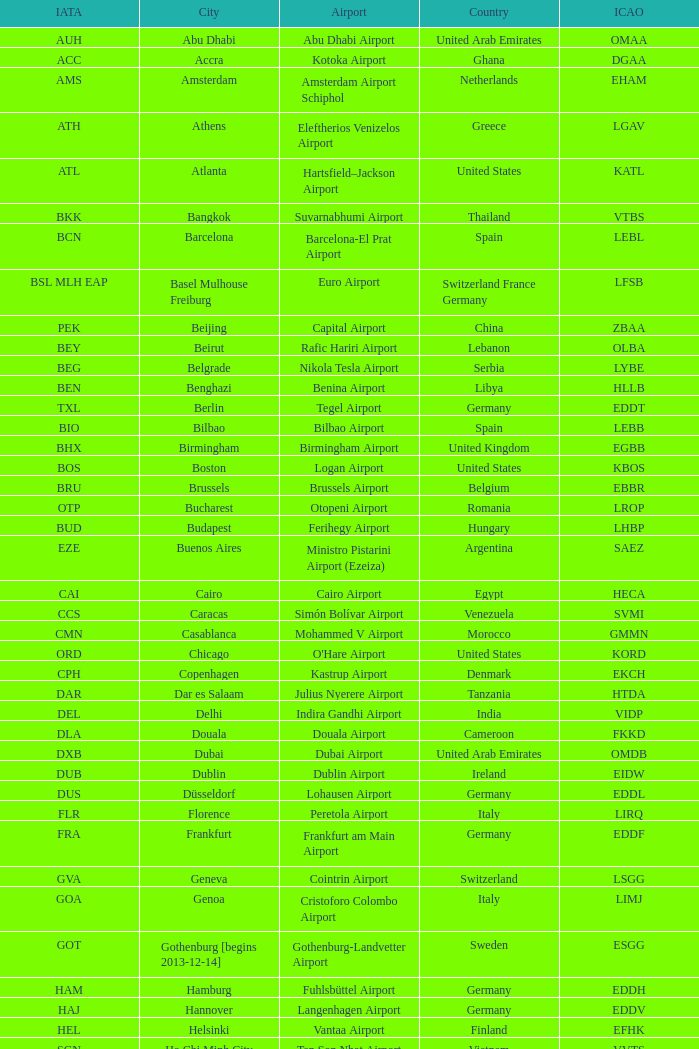Could you parse the entire table? {'header': ['IATA', 'City', 'Airport', 'Country', 'ICAO'], 'rows': [['AUH', 'Abu Dhabi', 'Abu Dhabi Airport', 'United Arab Emirates', 'OMAA'], ['ACC', 'Accra', 'Kotoka Airport', 'Ghana', 'DGAA'], ['AMS', 'Amsterdam', 'Amsterdam Airport Schiphol', 'Netherlands', 'EHAM'], ['ATH', 'Athens', 'Eleftherios Venizelos Airport', 'Greece', 'LGAV'], ['ATL', 'Atlanta', 'Hartsfield–Jackson Airport', 'United States', 'KATL'], ['BKK', 'Bangkok', 'Suvarnabhumi Airport', 'Thailand', 'VTBS'], ['BCN', 'Barcelona', 'Barcelona-El Prat Airport', 'Spain', 'LEBL'], ['BSL MLH EAP', 'Basel Mulhouse Freiburg', 'Euro Airport', 'Switzerland France Germany', 'LFSB'], ['PEK', 'Beijing', 'Capital Airport', 'China', 'ZBAA'], ['BEY', 'Beirut', 'Rafic Hariri Airport', 'Lebanon', 'OLBA'], ['BEG', 'Belgrade', 'Nikola Tesla Airport', 'Serbia', 'LYBE'], ['BEN', 'Benghazi', 'Benina Airport', 'Libya', 'HLLB'], ['TXL', 'Berlin', 'Tegel Airport', 'Germany', 'EDDT'], ['BIO', 'Bilbao', 'Bilbao Airport', 'Spain', 'LEBB'], ['BHX', 'Birmingham', 'Birmingham Airport', 'United Kingdom', 'EGBB'], ['BOS', 'Boston', 'Logan Airport', 'United States', 'KBOS'], ['BRU', 'Brussels', 'Brussels Airport', 'Belgium', 'EBBR'], ['OTP', 'Bucharest', 'Otopeni Airport', 'Romania', 'LROP'], ['BUD', 'Budapest', 'Ferihegy Airport', 'Hungary', 'LHBP'], ['EZE', 'Buenos Aires', 'Ministro Pistarini Airport (Ezeiza)', 'Argentina', 'SAEZ'], ['CAI', 'Cairo', 'Cairo Airport', 'Egypt', 'HECA'], ['CCS', 'Caracas', 'Simón Bolívar Airport', 'Venezuela', 'SVMI'], ['CMN', 'Casablanca', 'Mohammed V Airport', 'Morocco', 'GMMN'], ['ORD', 'Chicago', "O'Hare Airport", 'United States', 'KORD'], ['CPH', 'Copenhagen', 'Kastrup Airport', 'Denmark', 'EKCH'], ['DAR', 'Dar es Salaam', 'Julius Nyerere Airport', 'Tanzania', 'HTDA'], ['DEL', 'Delhi', 'Indira Gandhi Airport', 'India', 'VIDP'], ['DLA', 'Douala', 'Douala Airport', 'Cameroon', 'FKKD'], ['DXB', 'Dubai', 'Dubai Airport', 'United Arab Emirates', 'OMDB'], ['DUB', 'Dublin', 'Dublin Airport', 'Ireland', 'EIDW'], ['DUS', 'Düsseldorf', 'Lohausen Airport', 'Germany', 'EDDL'], ['FLR', 'Florence', 'Peretola Airport', 'Italy', 'LIRQ'], ['FRA', 'Frankfurt', 'Frankfurt am Main Airport', 'Germany', 'EDDF'], ['GVA', 'Geneva', 'Cointrin Airport', 'Switzerland', 'LSGG'], ['GOA', 'Genoa', 'Cristoforo Colombo Airport', 'Italy', 'LIMJ'], ['GOT', 'Gothenburg [begins 2013-12-14]', 'Gothenburg-Landvetter Airport', 'Sweden', 'ESGG'], ['HAM', 'Hamburg', 'Fuhlsbüttel Airport', 'Germany', 'EDDH'], ['HAJ', 'Hannover', 'Langenhagen Airport', 'Germany', 'EDDV'], ['HEL', 'Helsinki', 'Vantaa Airport', 'Finland', 'EFHK'], ['SGN', 'Ho Chi Minh City', 'Tan Son Nhat Airport', 'Vietnam', 'VVTS'], ['HKG', 'Hong Kong', 'Chek Lap Kok Airport', 'Hong Kong', 'VHHH'], ['IST', 'Istanbul', 'Atatürk Airport', 'Turkey', 'LTBA'], ['CGK', 'Jakarta', 'Soekarno–Hatta Airport', 'Indonesia', 'WIII'], ['JED', 'Jeddah', 'King Abdulaziz Airport', 'Saudi Arabia', 'OEJN'], ['JNB', 'Johannesburg', 'OR Tambo Airport', 'South Africa', 'FAJS'], ['KHI', 'Karachi', 'Jinnah Airport', 'Pakistan', 'OPKC'], ['KBP', 'Kiev', 'Boryspil International Airport', 'Ukraine', 'UKBB'], ['LOS', 'Lagos', 'Murtala Muhammed Airport', 'Nigeria', 'DNMM'], ['LBV', 'Libreville', "Leon M'ba Airport", 'Gabon', 'FOOL'], ['LIS', 'Lisbon', 'Portela Airport', 'Portugal', 'LPPT'], ['LCY', 'London', 'City Airport', 'United Kingdom', 'EGLC'], ['LGW', 'London [begins 2013-12-14]', 'Gatwick Airport', 'United Kingdom', 'EGKK'], ['LHR', 'London', 'Heathrow Airport', 'United Kingdom', 'EGLL'], ['LAX', 'Los Angeles', 'Los Angeles International Airport', 'United States', 'KLAX'], ['LUG', 'Lugano', 'Agno Airport', 'Switzerland', 'LSZA'], ['LUX', 'Luxembourg City', 'Findel Airport', 'Luxembourg', 'ELLX'], ['LYS', 'Lyon', 'Saint-Exupéry Airport', 'France', 'LFLL'], ['MAD', 'Madrid', 'Madrid-Barajas Airport', 'Spain', 'LEMD'], ['SSG', 'Malabo', 'Saint Isabel Airport', 'Equatorial Guinea', 'FGSL'], ['AGP', 'Malaga', 'Málaga-Costa del Sol Airport', 'Spain', 'LEMG'], ['MAN', 'Manchester', 'Ringway Airport', 'United Kingdom', 'EGCC'], ['MNL', 'Manila', 'Ninoy Aquino Airport', 'Philippines', 'RPLL'], ['RAK', 'Marrakech [begins 2013-11-01]', 'Menara Airport', 'Morocco', 'GMMX'], ['MIA', 'Miami', 'Miami Airport', 'United States', 'KMIA'], ['MXP', 'Milan', 'Malpensa Airport', 'Italy', 'LIMC'], ['MSP', 'Minneapolis', 'Minneapolis Airport', 'United States', 'KMSP'], ['YUL', 'Montreal', 'Pierre Elliott Trudeau Airport', 'Canada', 'CYUL'], ['DME', 'Moscow', 'Domodedovo Airport', 'Russia', 'UUDD'], ['BOM', 'Mumbai', 'Chhatrapati Shivaji Airport', 'India', 'VABB'], ['MUC', 'Munich', 'Franz Josef Strauss Airport', 'Germany', 'EDDM'], ['MCT', 'Muscat', 'Seeb Airport', 'Oman', 'OOMS'], ['NBO', 'Nairobi', 'Jomo Kenyatta Airport', 'Kenya', 'HKJK'], ['EWR', 'Newark', 'Liberty Airport', 'United States', 'KEWR'], ['JFK', 'New York City', 'John F Kennedy Airport', 'United States', 'KJFK'], ['NCE', 'Nice', "Côte d'Azur Airport", 'France', 'LFMN'], ['NUE', 'Nuremberg', 'Nuremberg Airport', 'Germany', 'EDDN'], ['OSL', 'Oslo', 'Gardermoen Airport', 'Norway', 'ENGM'], ['PMI', 'Palma de Mallorca', 'Palma de Mallorca Airport', 'Spain', 'LFPA'], ['CDG', 'Paris', 'Charles de Gaulle Airport', 'France', 'LFPG'], ['OPO', 'Porto', 'Francisco de Sa Carneiro Airport', 'Portugal', 'LPPR'], ['PRG', 'Prague', 'Ruzyně Airport', 'Czech Republic', 'LKPR'], ['RIX', 'Riga', 'Riga Airport', 'Latvia', 'EVRA'], ['GIG', 'Rio de Janeiro [resumes 2014-7-14]', 'Galeão Airport', 'Brazil', 'SBGL'], ['RUH', 'Riyadh', 'King Khalid Airport', 'Saudi Arabia', 'OERK'], ['FCO', 'Rome', 'Leonardo da Vinci Airport', 'Italy', 'LIRF'], ['LED', 'Saint Petersburg', 'Pulkovo Airport', 'Russia', 'ULLI'], ['SFO', 'San Francisco', 'San Francisco Airport', 'United States', 'KSFO'], ['SCL', 'Santiago', 'Comodoro Arturo Benitez Airport', 'Chile', 'SCEL'], ['GRU', 'São Paulo', 'Guarulhos Airport', 'Brazil', 'SBGR'], ['SJJ', 'Sarajevo', 'Butmir Airport', 'Bosnia and Herzegovina', 'LQSA'], ['SEA', 'Seattle', 'Sea-Tac Airport', 'United States', 'KSEA'], ['PVG', 'Shanghai', 'Pudong Airport', 'China', 'ZSPD'], ['SIN', 'Singapore', 'Changi Airport', 'Singapore', 'WSSS'], ['SKP', 'Skopje', 'Alexander the Great Airport', 'Republic of Macedonia', 'LWSK'], ['SOF', 'Sofia', 'Vrazhdebna Airport', 'Bulgaria', 'LBSF'], ['ARN', 'Stockholm', 'Arlanda Airport', 'Sweden', 'ESSA'], ['STR', 'Stuttgart', 'Echterdingen Airport', 'Germany', 'EDDS'], ['TPE', 'Taipei', 'Taoyuan Airport', 'Taiwan', 'RCTP'], ['IKA', 'Tehran', 'Imam Khomeini Airport', 'Iran', 'OIIE'], ['TLV', 'Tel Aviv', 'Ben Gurion Airport', 'Israel', 'LLBG'], ['SKG', 'Thessaloniki', 'Macedonia Airport', 'Greece', 'LGTS'], ['TIA', 'Tirana', 'Nënë Tereza Airport', 'Albania', 'LATI'], ['NRT', 'Tokyo', 'Narita Airport', 'Japan', 'RJAA'], ['YYZ', 'Toronto', 'Pearson Airport', 'Canada', 'CYYZ'], ['TIP', 'Tripoli', 'Tripoli Airport', 'Libya', 'HLLT'], ['TUN', 'Tunis', 'Carthage Airport', 'Tunisia', 'DTTA'], ['TRN', 'Turin', 'Sandro Pertini Airport', 'Italy', 'LIMF'], ['VLC', 'Valencia', 'Valencia Airport', 'Spain', 'LEVC'], ['VCE', 'Venice', 'Marco Polo Airport', 'Italy', 'LIPZ'], ['VIE', 'Vienna', 'Schwechat Airport', 'Austria', 'LOWW'], ['WAW', 'Warsaw', 'Frederic Chopin Airport', 'Poland', 'EPWA'], ['IAD', 'Washington DC', 'Dulles Airport', 'United States', 'KIAD'], ['NSI', 'Yaounde', 'Yaounde Nsimalen Airport', 'Cameroon', 'FKYS'], ['EVN', 'Yerevan', 'Zvartnots Airport', 'Armenia', 'UDYZ'], ['ZRH', 'Zurich', 'Zurich Airport', 'Switzerland', 'LSZH']]} What is the IATA for Ringway Airport in the United Kingdom? MAN. 